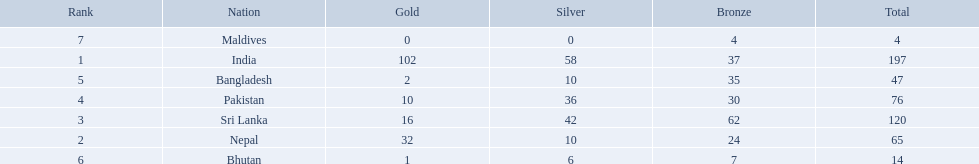What are all the countries listed in the table? India, Nepal, Sri Lanka, Pakistan, Bangladesh, Bhutan, Maldives. Which of these is not india? Nepal, Sri Lanka, Pakistan, Bangladesh, Bhutan, Maldives. Of these, which is first? Nepal. 